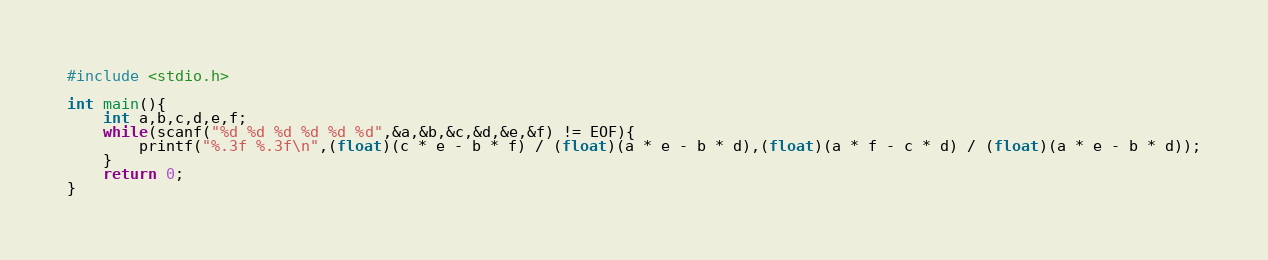Convert code to text. <code><loc_0><loc_0><loc_500><loc_500><_C_>#include <stdio.h>

int main(){
	int a,b,c,d,e,f;
	while(scanf("%d %d %d %d %d %d",&a,&b,&c,&d,&e,&f) != EOF){
		printf("%.3f %.3f\n",(float)(c * e - b * f) / (float)(a * e - b * d),(float)(a * f - c * d) / (float)(a * e - b * d));
	}
	return 0;
}</code> 